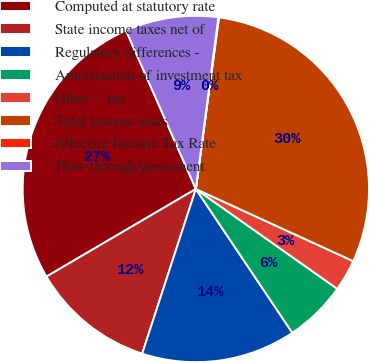Convert chart. <chart><loc_0><loc_0><loc_500><loc_500><pie_chart><fcel>Computed at statutory rate<fcel>State income taxes net of<fcel>Regulatory differences -<fcel>Amortization of investment tax<fcel>Other -- net<fcel>Total income taxes<fcel>Effective Income Tax Rate<fcel>Flow-through/permanent<nl><fcel>26.84%<fcel>11.55%<fcel>14.42%<fcel>5.81%<fcel>2.94%<fcel>29.71%<fcel>0.06%<fcel>8.68%<nl></chart> 